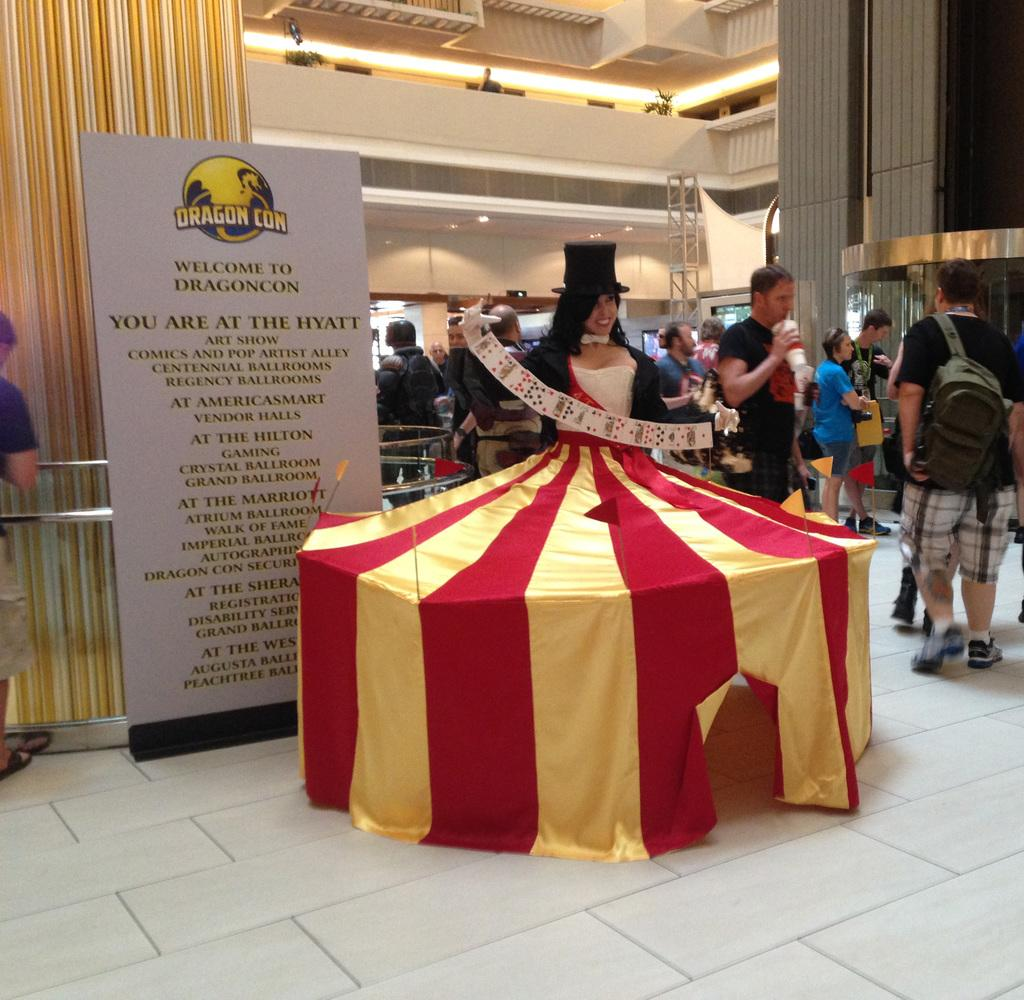How many people are in the image? There are people standing in the image, but the exact number is not specified. What distinguishes one person from the others? One person is wearing a different costume. What can be seen in the background of the image? There is a board, pillars, and lights in the image. Can you tell me how many baseballs are being thrown in the image? There is no mention of baseballs or any related activity in the image. 